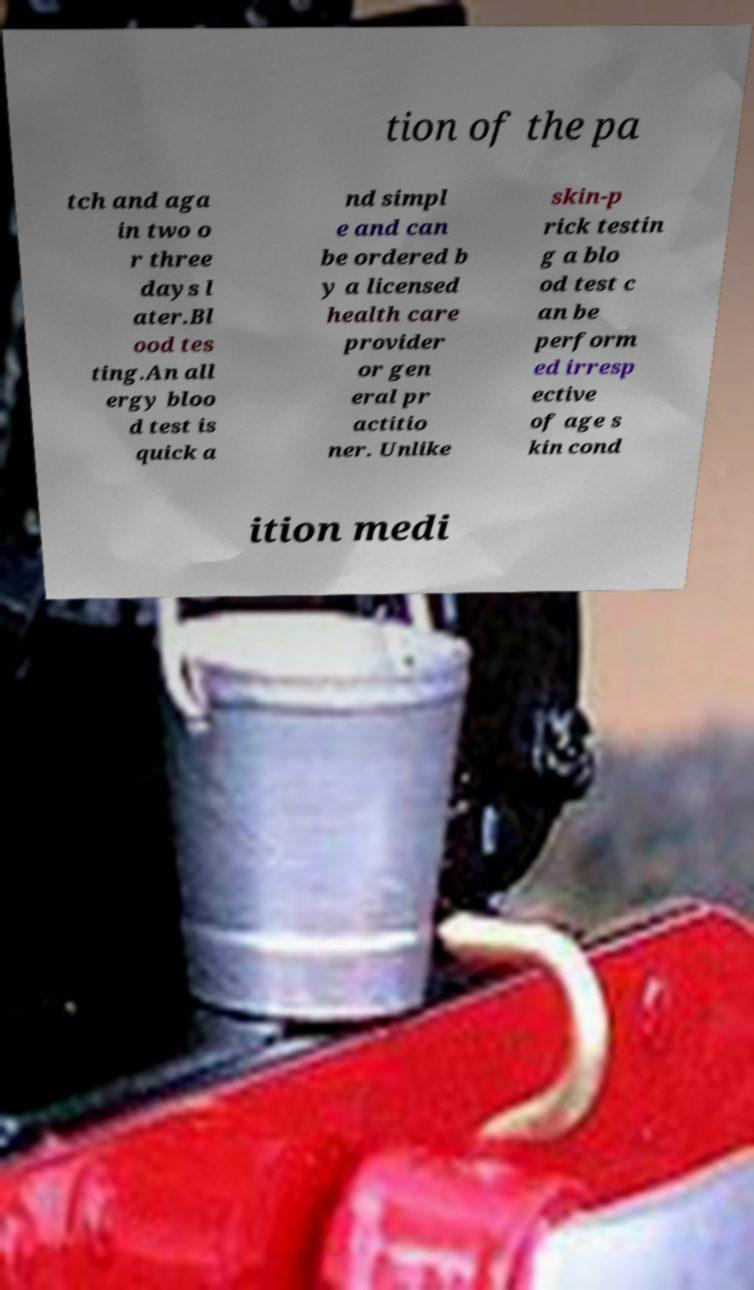Could you extract and type out the text from this image? tion of the pa tch and aga in two o r three days l ater.Bl ood tes ting.An all ergy bloo d test is quick a nd simpl e and can be ordered b y a licensed health care provider or gen eral pr actitio ner. Unlike skin-p rick testin g a blo od test c an be perform ed irresp ective of age s kin cond ition medi 